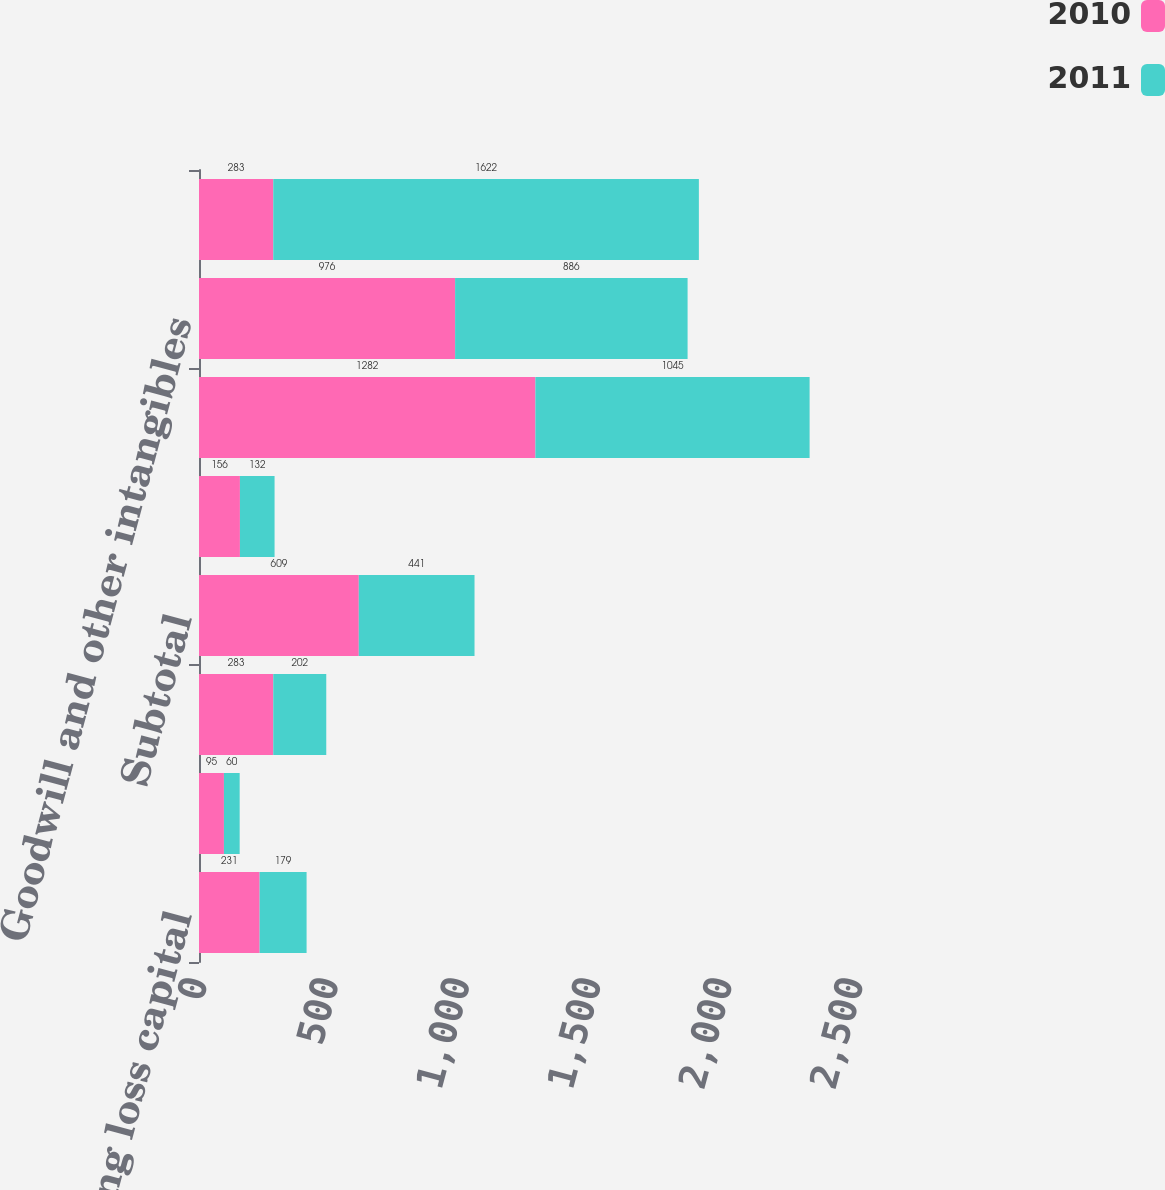Convert chart. <chart><loc_0><loc_0><loc_500><loc_500><stacked_bar_chart><ecel><fcel>Net operating loss capital<fcel>Landfill and environmental<fcel>Miscellaneous and other<fcel>Subtotal<fcel>Valuation allowance<fcel>Property and equipment<fcel>Goodwill and other intangibles<fcel>Net deferred tax liabilities<nl><fcel>2010<fcel>231<fcel>95<fcel>283<fcel>609<fcel>156<fcel>1282<fcel>976<fcel>283<nl><fcel>2011<fcel>179<fcel>60<fcel>202<fcel>441<fcel>132<fcel>1045<fcel>886<fcel>1622<nl></chart> 